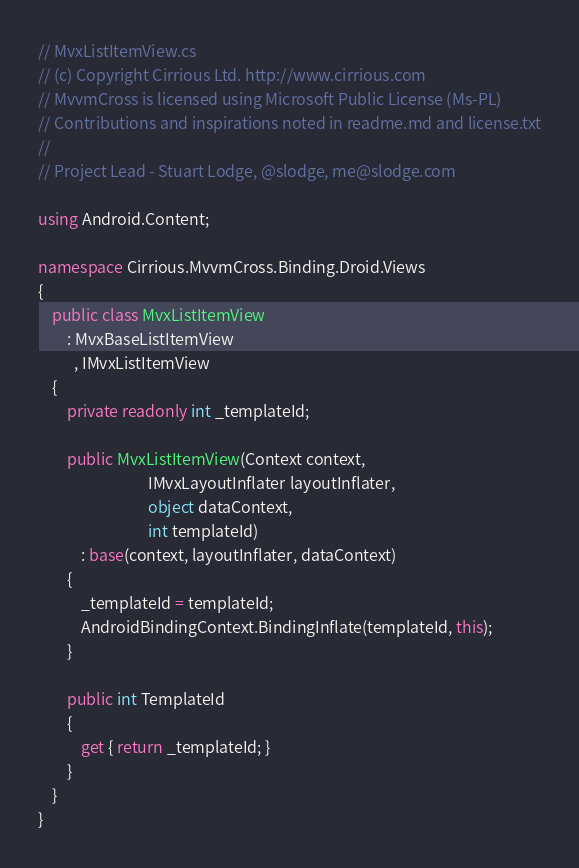Convert code to text. <code><loc_0><loc_0><loc_500><loc_500><_C#_>// MvxListItemView.cs
// (c) Copyright Cirrious Ltd. http://www.cirrious.com
// MvvmCross is licensed using Microsoft Public License (Ms-PL)
// Contributions and inspirations noted in readme.md and license.txt
// 
// Project Lead - Stuart Lodge, @slodge, me@slodge.com

using Android.Content;

namespace Cirrious.MvvmCross.Binding.Droid.Views
{
    public class MvxListItemView
        : MvxBaseListItemView
          , IMvxListItemView
    {
        private readonly int _templateId;

        public MvxListItemView(Context context,
                               IMvxLayoutInflater layoutInflater,
                               object dataContext,
                               int templateId)
            : base(context, layoutInflater, dataContext)
        {
            _templateId = templateId;
            AndroidBindingContext.BindingInflate(templateId, this);
        }

        public int TemplateId
        {
            get { return _templateId; }
        }
    }
}</code> 